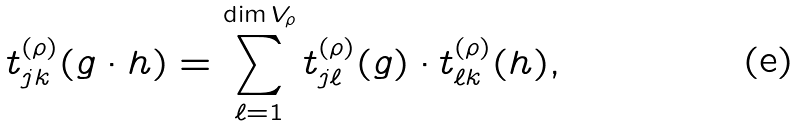Convert formula to latex. <formula><loc_0><loc_0><loc_500><loc_500>t _ { j k } ^ { ( \rho ) } ( g \cdot h ) = \sum _ { \ell = 1 } ^ { \dim V _ { \rho } } t _ { j \ell } ^ { ( \rho ) } ( g ) \cdot t _ { \ell k } ^ { ( \rho ) } ( h ) ,</formula> 